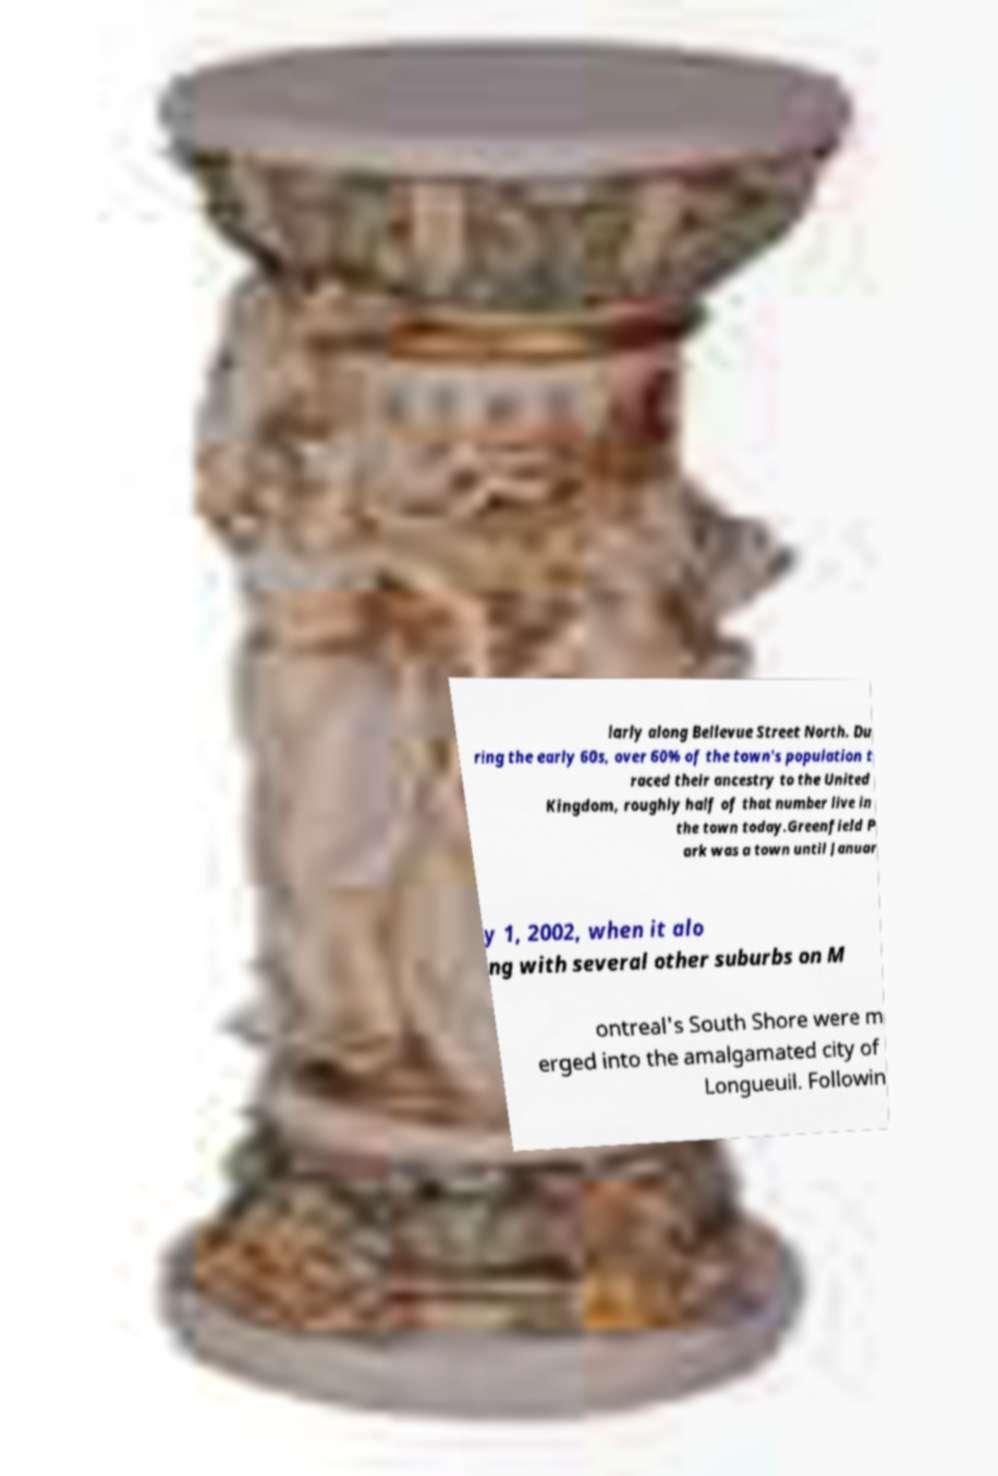What messages or text are displayed in this image? I need them in a readable, typed format. larly along Bellevue Street North. Du ring the early 60s, over 60% of the town's population t raced their ancestry to the United Kingdom, roughly half of that number live in the town today.Greenfield P ark was a town until Januar y 1, 2002, when it alo ng with several other suburbs on M ontreal's South Shore were m erged into the amalgamated city of Longueuil. Followin 